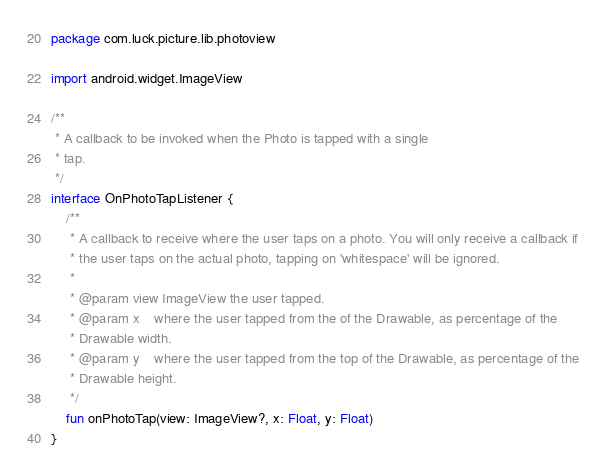Convert code to text. <code><loc_0><loc_0><loc_500><loc_500><_Kotlin_>package com.luck.picture.lib.photoview

import android.widget.ImageView

/**
 * A callback to be invoked when the Photo is tapped with a single
 * tap.
 */
interface OnPhotoTapListener {
    /**
     * A callback to receive where the user taps on a photo. You will only receive a callback if
     * the user taps on the actual photo, tapping on 'whitespace' will be ignored.
     *
     * @param view ImageView the user tapped.
     * @param x    where the user tapped from the of the Drawable, as percentage of the
     * Drawable width.
     * @param y    where the user tapped from the top of the Drawable, as percentage of the
     * Drawable height.
     */
    fun onPhotoTap(view: ImageView?, x: Float, y: Float)
}</code> 